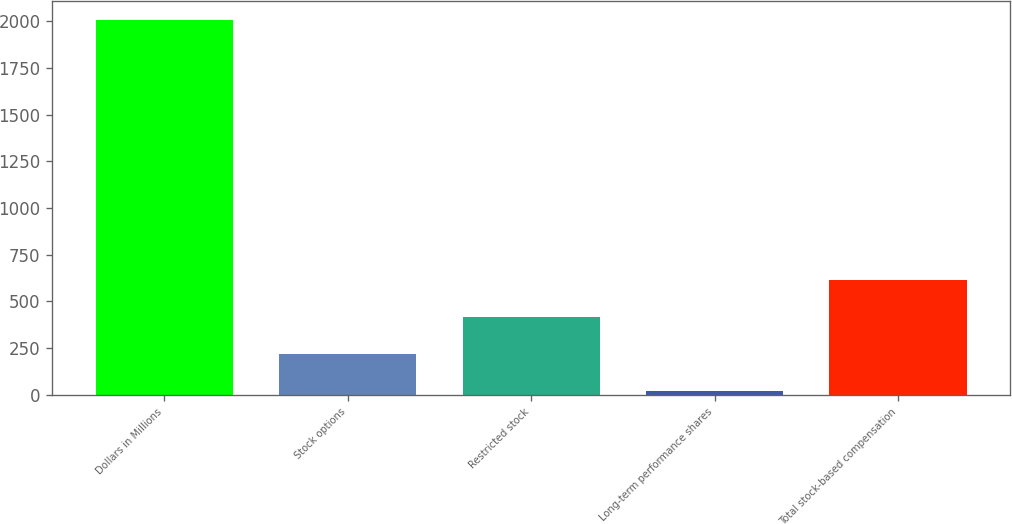Convert chart to OTSL. <chart><loc_0><loc_0><loc_500><loc_500><bar_chart><fcel>Dollars in Millions<fcel>Stock options<fcel>Restricted stock<fcel>Long-term performance shares<fcel>Total stock-based compensation<nl><fcel>2008<fcel>218.8<fcel>417.6<fcel>20<fcel>616.4<nl></chart> 